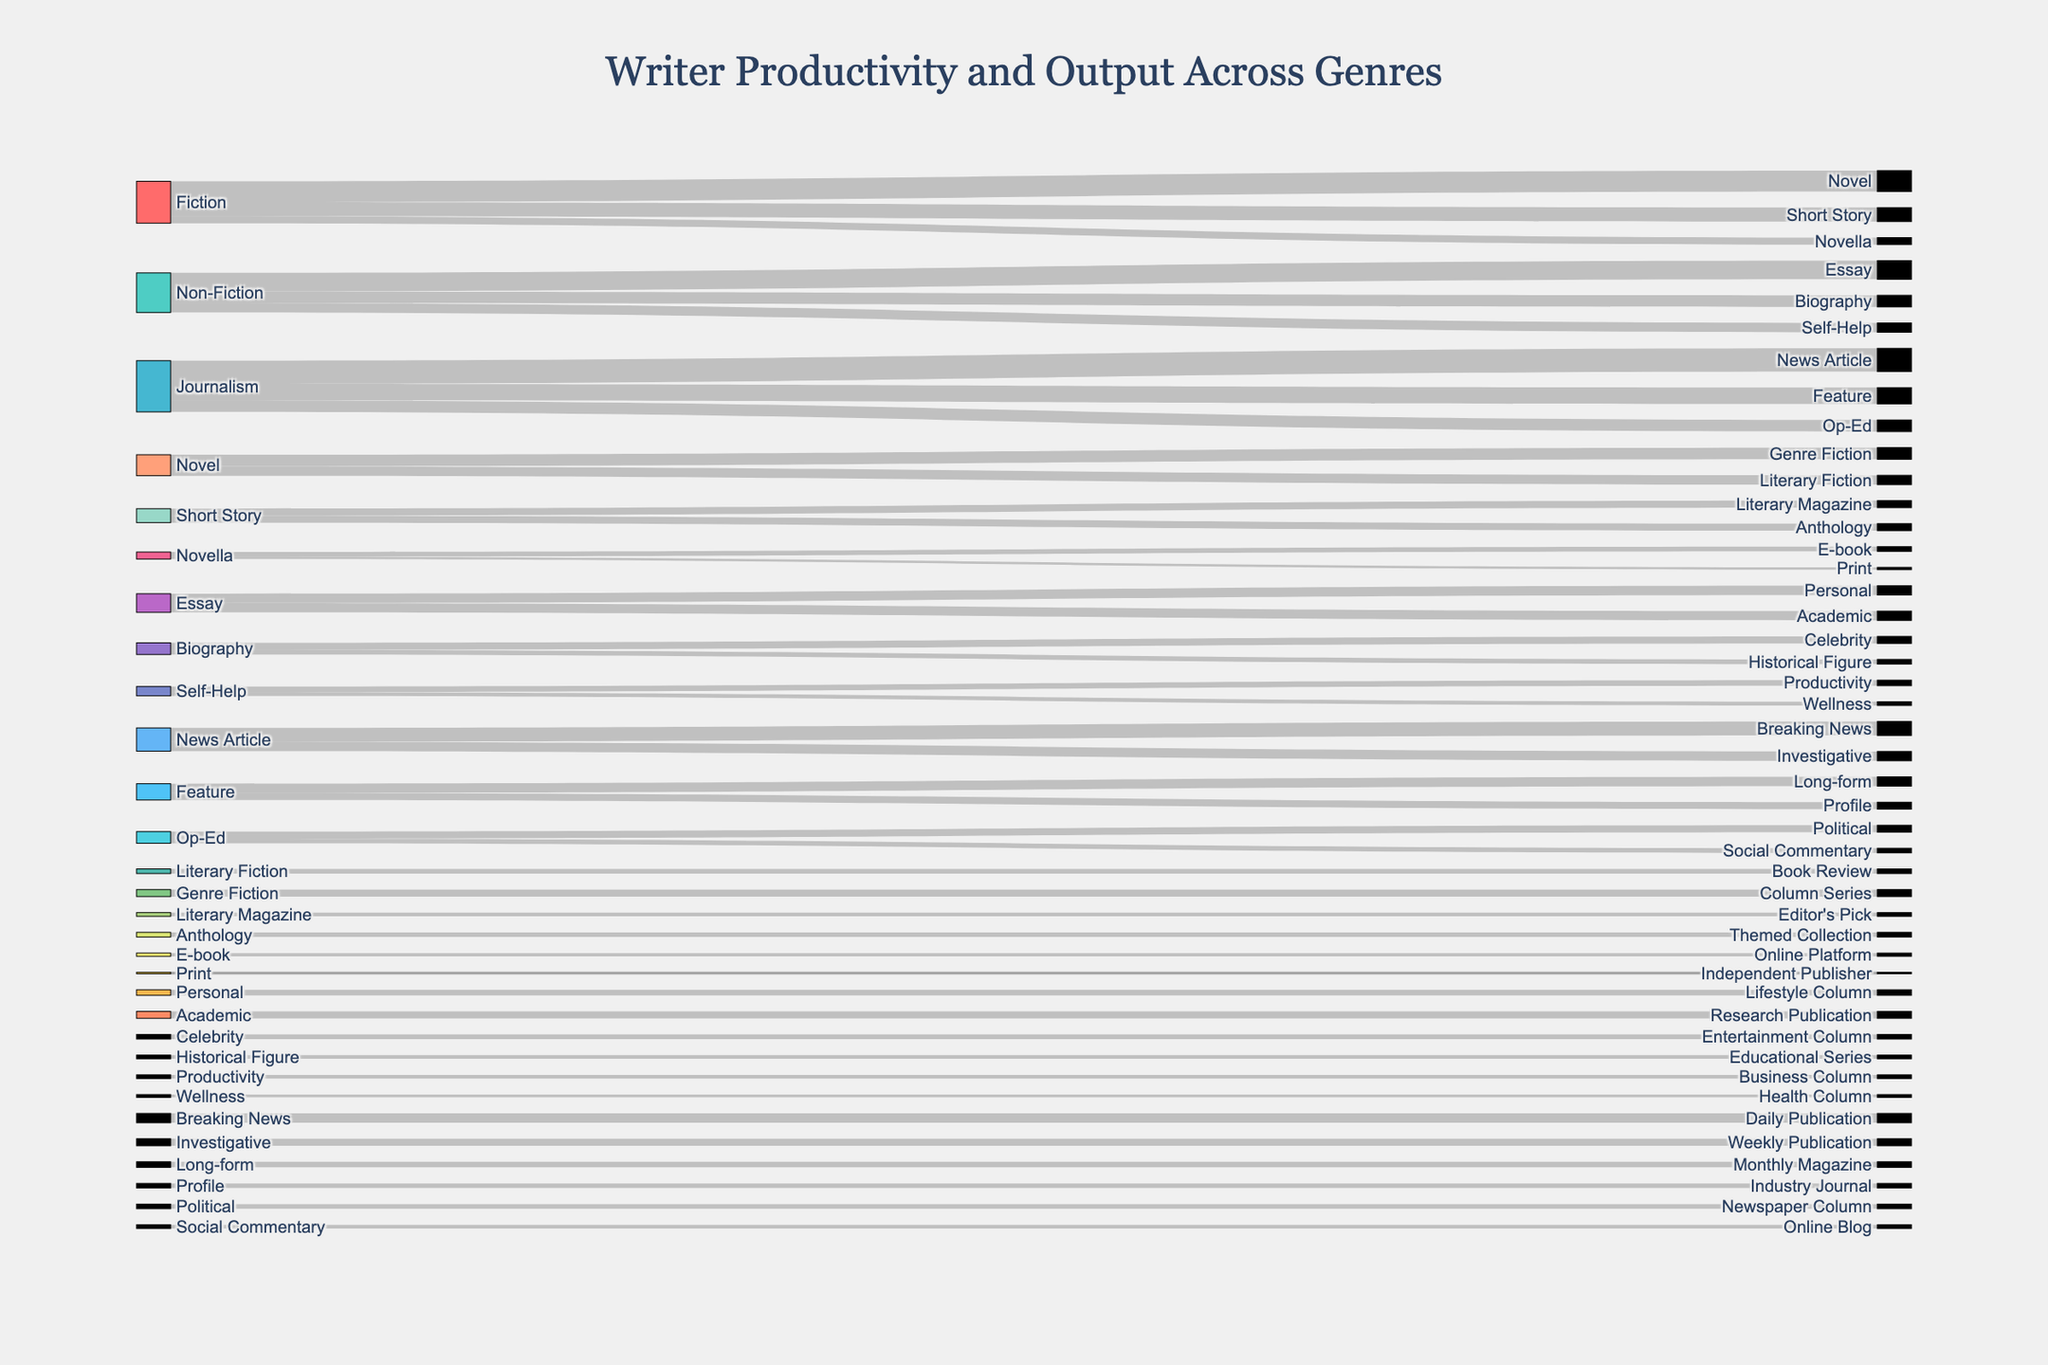How many columns are dedicated to Fiction? We count the number of unique targets directly from Fiction sources which are Novel, Short Story, and Novella, adding up to 3.
Answer: 3 What type of Non-Fiction has the highest productivity? In the Non-Fiction category, the highest value is associated with Essay with 40 units, compared to Biography with 25 and Self-Help with 20.
Answer: Essay Which News Article subtype has more output, Breaking News or Investigative? By checking the values associated with Breaking News (30) and Investigative (20), we see that Breaking News has higher output.
Answer: Breaking News How does the productivity of Novel compare to Short Story in Fiction? Novel has a value of 45, while Short Story has 30, meaning Novel has higher productivity.
Answer: Novel What are the two most productive types under Fiction? Fiction breaks down into Novel (45), Short Story (30), and Novella (15). The two highest are Novel and Short Story.
Answer: Novel, Short Story How many total outputs are there under Journalism? Summing Journalism's outputs: News Article (50), Feature (35), Op-Ed (25) results in a total of 110.
Answer: 110 Which types under Non-Fiction have an equal amount of output? Both subtypes of Essay — Personal and Academic — have equal values of 20.
Answer: Personal, Academic What has more productivity, Productivity columns or Wellness columns in Self-Help? Productivity has 12 units while Wellness has 8, so Productivity columns are higher.
Answer: Productivity What genres do Novellas contribute to more in terms of count? Novella breaks down into E-book and Print, with contributions being 10 and 5 respectively; counts are equal for types.
Answer: E-book, Print How does the output of Op-Ed's Political compare to Social Commentary? Political has 15 units and Social Commentary has 10, making Political the higher output option.
Answer: Political 